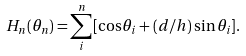<formula> <loc_0><loc_0><loc_500><loc_500>H _ { n } ( \theta _ { n } ) = \sum ^ { n } _ { i } [ \cos \theta _ { i } + ( d / h ) \sin \theta _ { i } ] .</formula> 